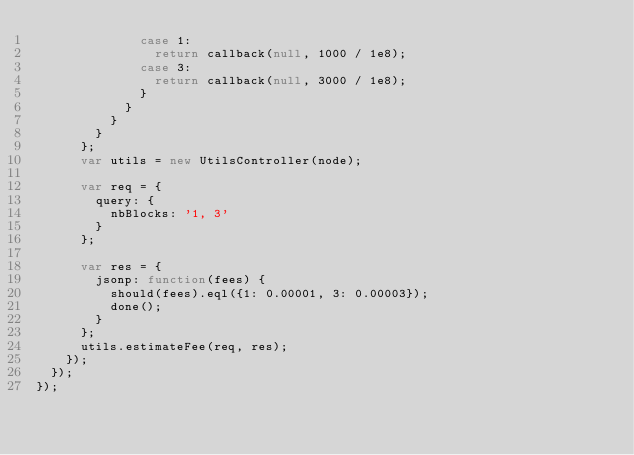Convert code to text. <code><loc_0><loc_0><loc_500><loc_500><_JavaScript_>              case 1:
                return callback(null, 1000 / 1e8);
              case 3:
                return callback(null, 3000 / 1e8);
              }
            }
          }
        }
      };
      var utils = new UtilsController(node);

      var req = {
        query: {
          nbBlocks: '1, 3'
        }
      };

      var res = {
        jsonp: function(fees) {
          should(fees).eql({1: 0.00001, 3: 0.00003});
          done();
        }
      };
      utils.estimateFee(req, res);
    });
  });
});
</code> 